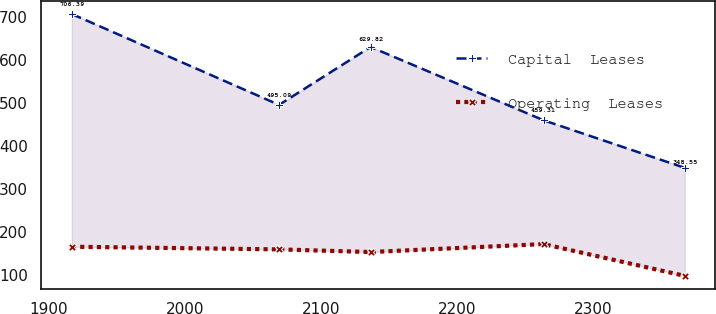<chart> <loc_0><loc_0><loc_500><loc_500><line_chart><ecel><fcel>Capital  Leases<fcel>Operating  Leases<nl><fcel>1916.92<fcel>706.39<fcel>165.08<nl><fcel>2069.12<fcel>495.09<fcel>158.91<nl><fcel>2136.33<fcel>629.82<fcel>152.74<nl><fcel>2263.41<fcel>459.31<fcel>171.25<nl><fcel>2367.17<fcel>348.55<fcel>97.28<nl></chart> 